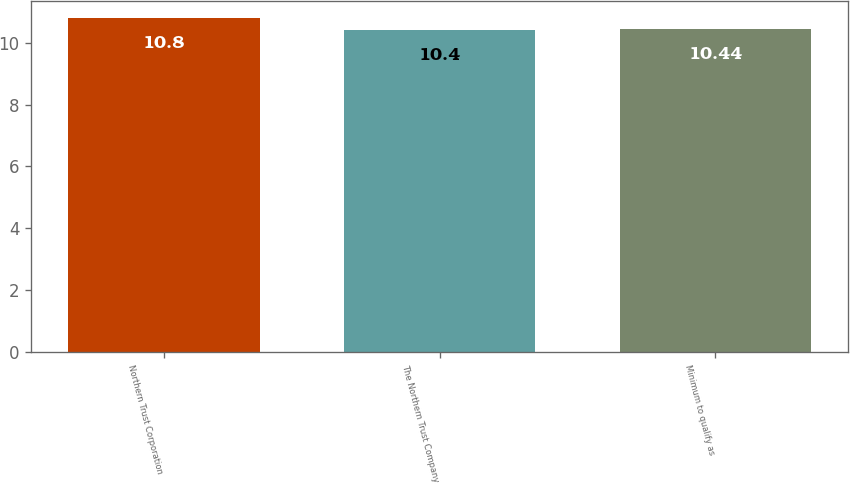<chart> <loc_0><loc_0><loc_500><loc_500><bar_chart><fcel>Northern Trust Corporation<fcel>The Northern Trust Company<fcel>Minimum to qualify as<nl><fcel>10.8<fcel>10.4<fcel>10.44<nl></chart> 